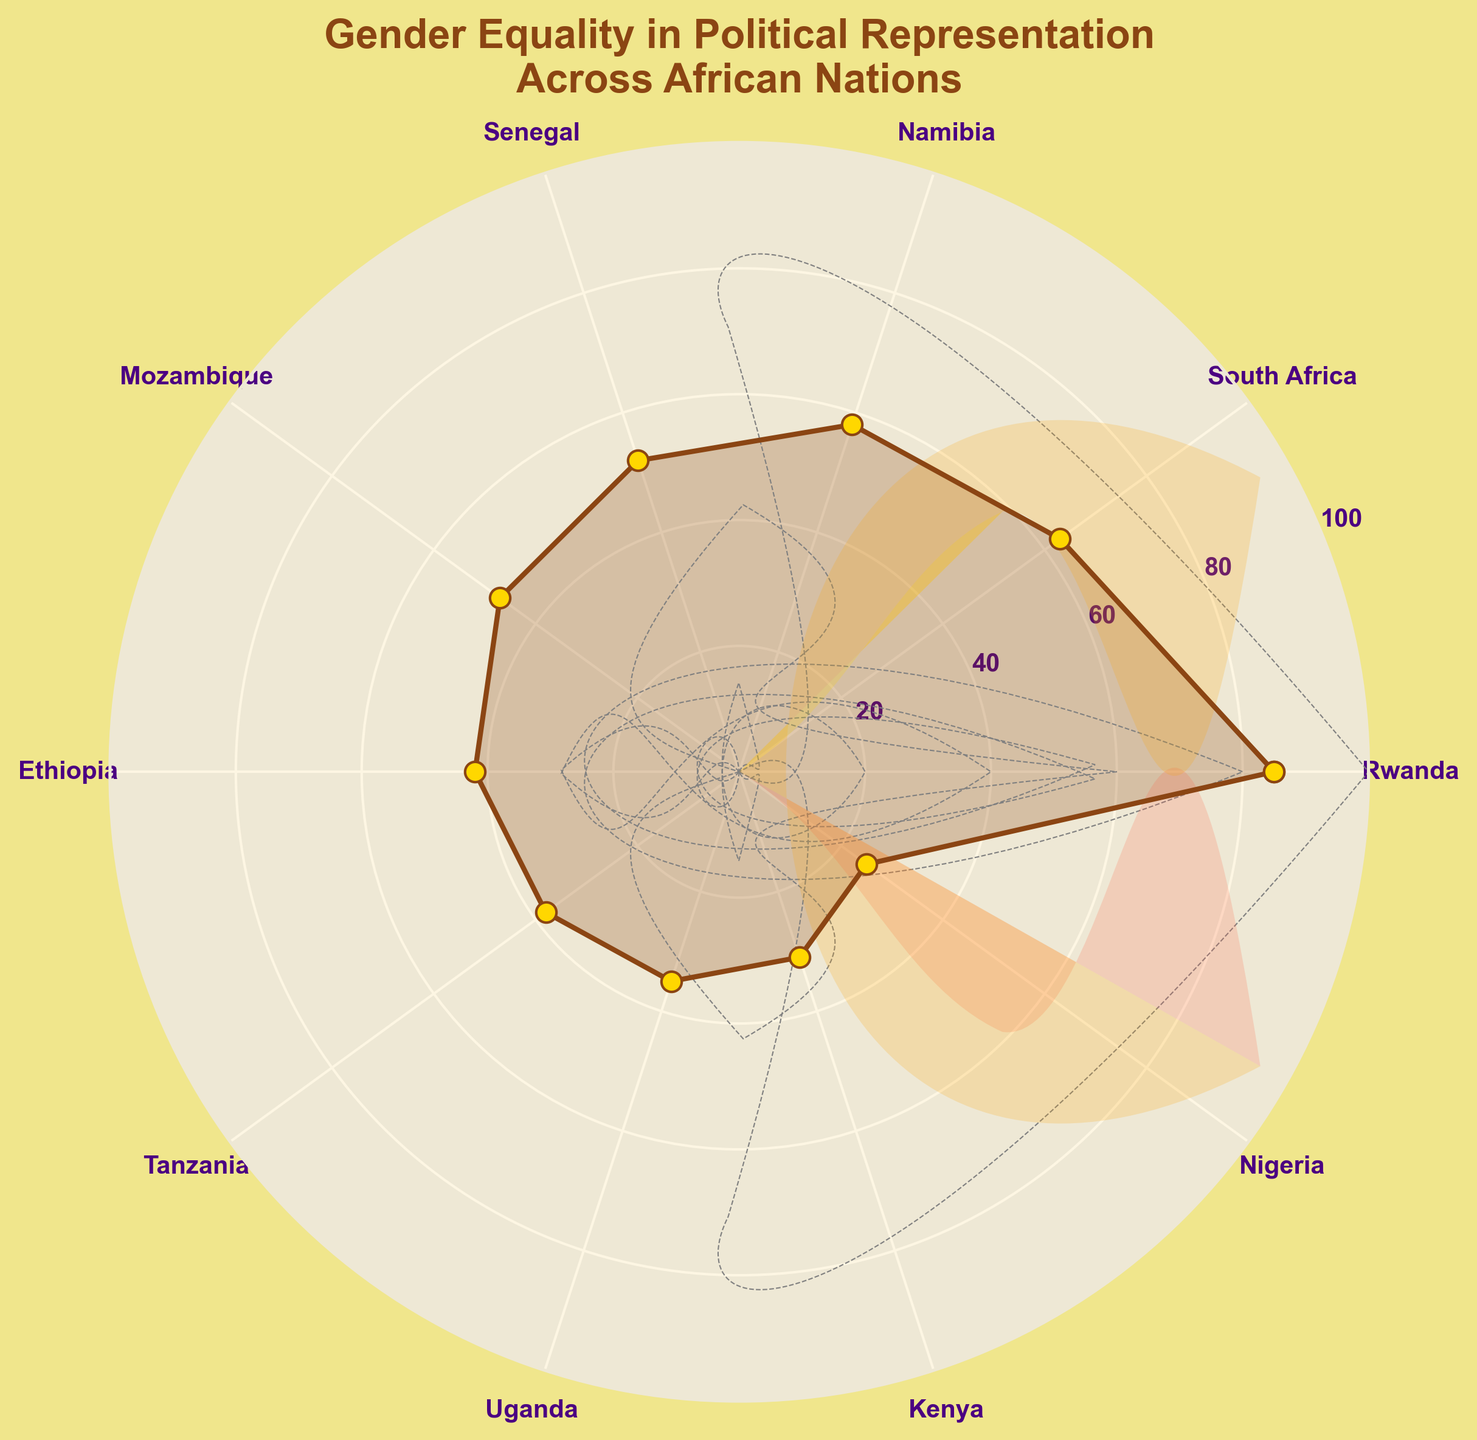What is the title of the figure? The title is usually displayed prominently at the top of the figure. In this figure, it provides a description of what the data represents.
Answer: Gender Equality in Political Representation Across African Nations Which country has the highest gender equality score? The country with the highest score will have the most prominent marker point, usually found by looking at the end of the radar plot.
Answer: Rwanda What is the gender equality score for Nigeria? By locating Nigeria around the outer ring of the radar plot and following the corresponding line to where it intersects with the scale, we can identify its score.
Answer: 25 How many countries are presented in the figure? Count the number of distinct country labels around the axes of the radar chart to determine the total number presented.
Answer: 10 Which country has the lowest gender equality score, and what is it? Identify the country marker closest to the center of the radar plot, which indicates the lowest score. Nigeria can be identified as having the lowest score by following its line.
Answer: Nigeria, 25 What is the average gender equality score of the top three countries? First, identify the top three countries with the highest scores (Rwanda, South Africa, and Namibia). Then sum their scores (85+63+58) and divide by 3.
Answer: (85+63+58)/3 = 68.67 Which countries have a score greater than 50? Locate and list all countries whose markers fall in the upper half of the radar plot, above the 50 mark.
Answer: Rwanda, South Africa, Namibia, Senegal What is the range of gender equality scores presented in the chart? Determine the highest score (Rwanda, 85) and the lowest score (Nigeria, 25), then calculate the difference.
Answer: 85-25 = 60 How many countries have their scores between 30 and 50 inclusive? Count the countries whose markers fall within the 30 to 50 range on the radar chart.
Answer: 4 (Mozambique, Ethiopia, Tanzania, Uganda) Which country falls closest to the midpoint (50) in the Gender Equality score? Identify the country with a marker nearest to the middle circle line, representing a score of 50.
Answer: Senegal 